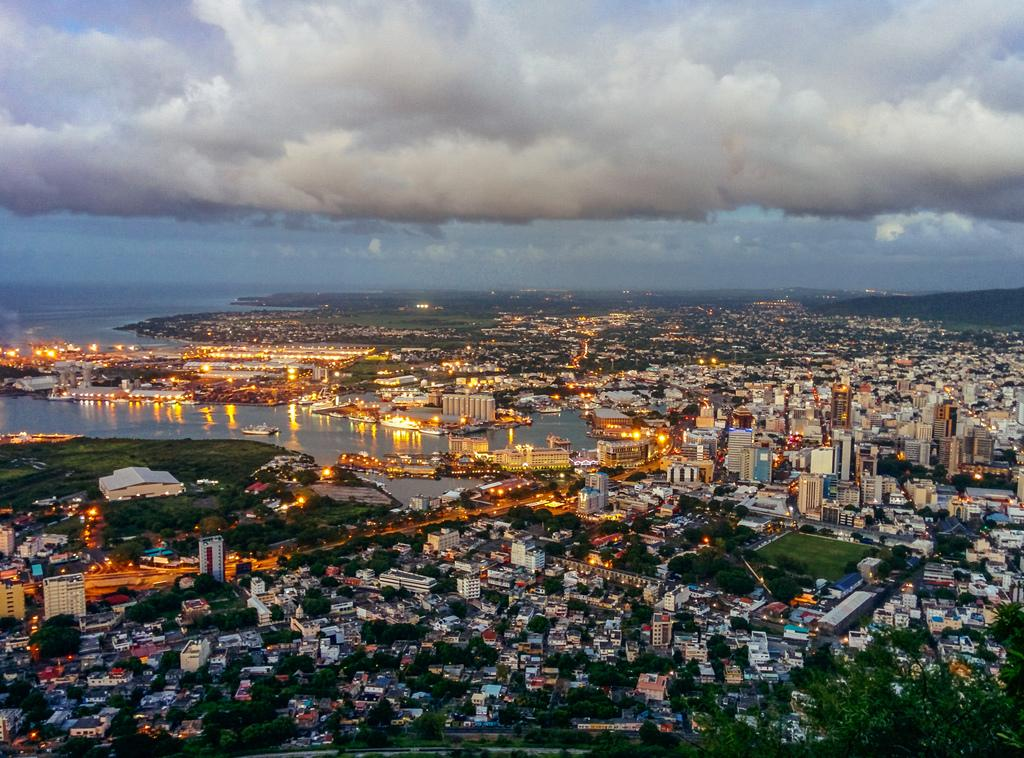What type of view is provided in the image? The image is an aerial view. What structures can be seen from this perspective? There are buildings visible in the image. What natural elements are present in the image? Trees, grass, hills, and water are present in the image. What man-made features can be seen? There is a road visible in the image. Are there any vehicles or vessels in the image? Ships are present in the water. What is visible in the sky? Clouds are present in the sky. What type of pencil can be seen in the image? There is no pencil present in the image. What scent is associated with the clouds in the image? Clouds do not have a scent, and there is no mention of any scents in the image. 